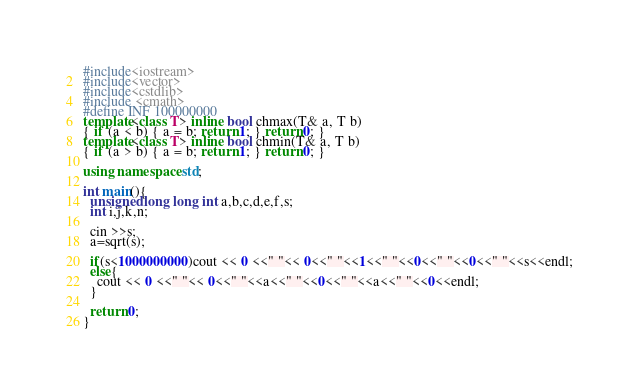Convert code to text. <code><loc_0><loc_0><loc_500><loc_500><_C++_>#include<iostream>
#include<vector>
#include<cstdlib>
#include <cmath>
#define INF 100000000
template<class T> inline bool chmax(T& a, T b)
{ if (a < b) { a = b; return 1; } return 0; }
template<class T> inline bool chmin(T& a, T b)
{ if (a > b) { a = b; return 1; } return 0; }

using namespace std;

int main(){
  unsigned long long int a,b,c,d,e,f,s;
  int i,j,k,n;

  cin >>s;
  a=sqrt(s);

  if(s<1000000000)cout << 0 <<" "<< 0<<" "<<1<<" "<<0<<" "<<0<<" "<<s<<endl;
  else{
    cout << 0 <<" "<< 0<<" "<<a<<" "<<0<<" "<<a<<" "<<0<<endl;
  }

  return 0;
}</code> 